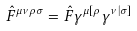Convert formula to latex. <formula><loc_0><loc_0><loc_500><loc_500>\hat { F } ^ { \mu \nu \rho \sigma } = \hat { F } \gamma ^ { \mu [ \rho } \gamma ^ { \nu | \sigma ] }</formula> 